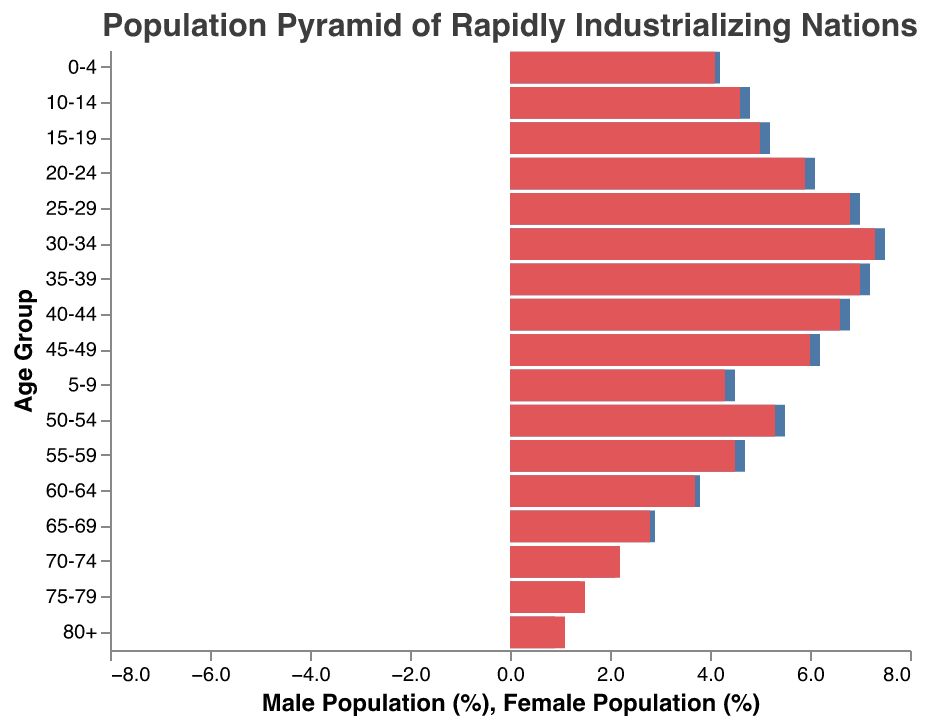What is the title of the figure? The title can be seen at the top of the figure, reading "Population Pyramid of Rapidly Industrializing Nations".
Answer: Population Pyramid of Rapidly Industrializing Nations Which age group has the highest percentage of males? The age group with the longest bar in the Male section represents the highest percentage. In this figure, the age group 30-34 has the highest percentage of males at -7.5%.
Answer: 30-34 Which age group has the smallest percentage of females? By checking the shortest bar on the Female side, the 80+ age group represents the smallest percentage with 1.1%.
Answer: 80+ What's the total percentage of the population in the 20-24 age group? Add the male and female percentages for the 20-24 age group: 6.1 (males) + 5.9 (females) = 12.0%.
Answer: 12.0% How does the percentage of females in the 25-29 age group compare to the 30-34 age group? The percentage of females in the 25-29 age group is 6.8%, while in the 30-34 age group, it is 7.3%. Comparatively, the 30-34 group has a higher percentage.
Answer: 30-34 group is higher How does the service of males in the 40-44 age group compare to that of females in the same group? The percentage for males in the 40-44 age group is -6.8%, while for females it is 6.6%. Males have a slightly higher population percentage than females in this group.
Answer: Males are slightly higher Which age group sees the first marked decrease in male percentage compared to the previous group? Compare the male percentages into each age group, observing the first noticeable decrease. Both 35-39 group (7.2%) and 40-44 group (6.8%) show significant drops compared to 30-34 (7.5%).
Answer: 35-39 What is the difference between the male and female population percentages in the 15-19 age group? For the 15-19 age group, subtract the male percentage from the female percentage: 5.0% - 5.2% = -0.2%.
Answer: -0.2% In which age group is the gender population difference most balanced? Look for the age group where the bars for males and females are closest in length. The 65-69 age group has percentages of 2.9% (male) and 2.8% (female), making it the most balanced.
Answer: 65-69 How does the population distribution of the working-age population (20-64 years) compare to the non-working-age population (0-19 and 65+ years)? Sum the populations for working-age groups (20-64): 6.1+5.9, 7.0+6.8, 7.5+7.3, 7.2+7.0, 6.8+6.6, and 6.2+6.0. This totals to 113%. Sum non-working-age groups (0-19 and 65+): 4.2+4.1, 4.5+4.3, 4.8+4.6, 5.2+5.0, 2.9+2.8, 2.1+2.2, 1.4+1.5, 0.9+1.1. This totals to approx 71.5%. The working-age population is predominantly higher.
Answer: Working-age population is higher 